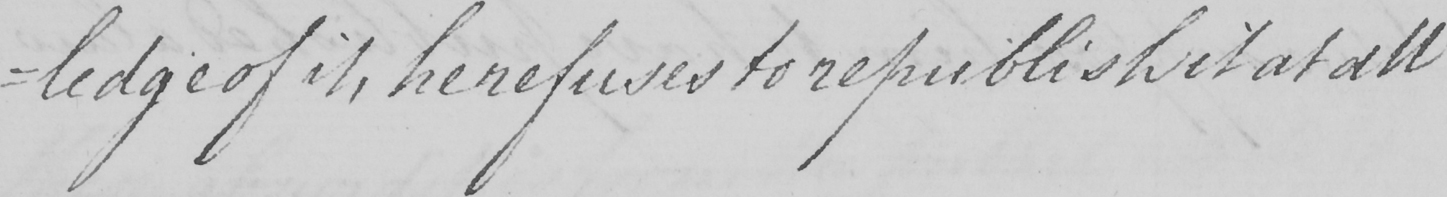Please provide the text content of this handwritten line. -ledge of it , he refuses to republish it at all 